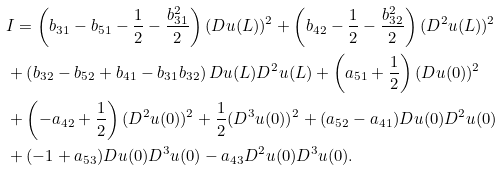Convert formula to latex. <formula><loc_0><loc_0><loc_500><loc_500>& I = \left ( b _ { 3 1 } - b _ { 5 1 } - \frac { 1 } { 2 } - \frac { b _ { 3 1 } ^ { 2 } } { 2 } \right ) ( D u ( L ) ) ^ { 2 } + \left ( b _ { 4 2 } - \frac { 1 } { 2 } - \frac { b _ { 3 2 } ^ { 2 } } { 2 } \right ) ( D ^ { 2 } u ( L ) ) ^ { 2 } \\ & + \left ( b _ { 3 2 } - b _ { 5 2 } + b _ { 4 1 } - b _ { 3 1 } b _ { 3 2 } \right ) D u ( L ) D ^ { 2 } u ( L ) + \left ( a _ { 5 1 } + \frac { 1 } { 2 } \right ) ( D u ( 0 ) ) ^ { 2 } \\ & + \left ( - a _ { 4 2 } + \frac { 1 } { 2 } \right ) ( D ^ { 2 } u ( 0 ) ) ^ { 2 } + \frac { 1 } { 2 } ( D ^ { 3 } u ( 0 ) ) ^ { 2 } + ( a _ { 5 2 } - a _ { 4 1 } ) D u ( 0 ) D ^ { 2 } u ( 0 ) \\ & + ( - 1 + a _ { 5 3 } ) D u ( 0 ) D ^ { 3 } u ( 0 ) - a _ { 4 3 } D ^ { 2 } u ( 0 ) D ^ { 3 } u ( 0 ) .</formula> 